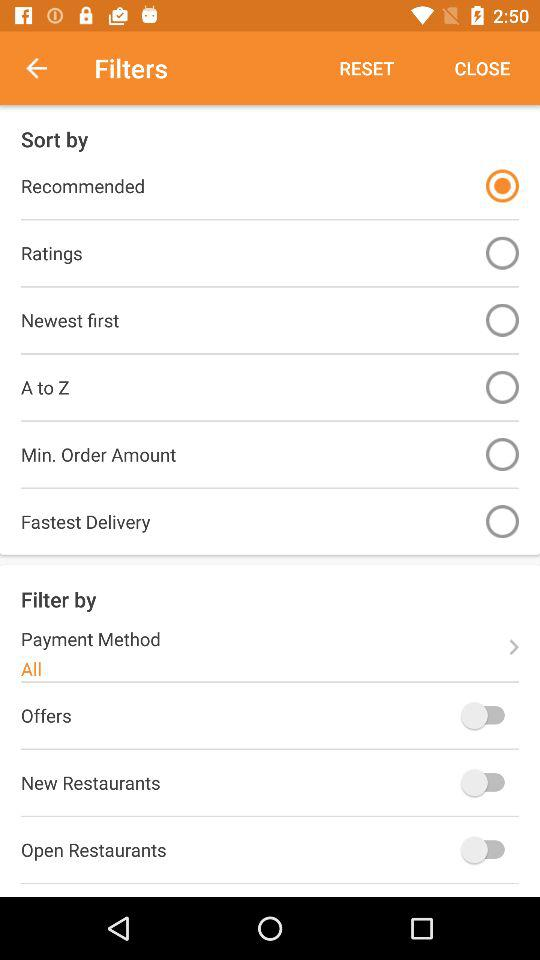Which option has been selected? The selected options are "Recommended" and "All". 